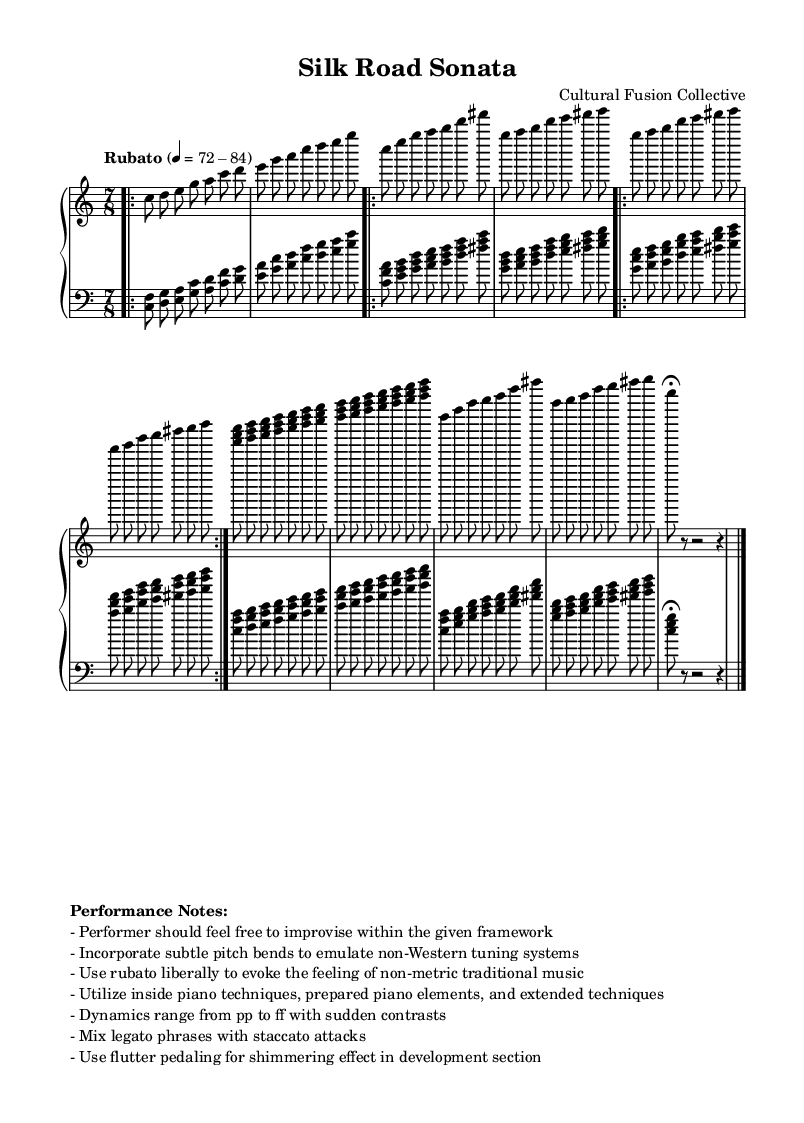What is the time signature of this music? The time signature is indicated at the beginning of the score, shown as 7/8. This is found in the section that specifies the rhythmic structure of the piece.
Answer: 7/8 What is the range of dynamics used in the piece? The dynamics range from "pp" (pianissimo) to "ff" (fortissimo), as noted in the performance notes section, indicating the extremes of quiet and loud playing within the composition.
Answer: pp to ff What is the tempo marking for the piece? The tempo marking is found in the score, indicating "Rubato" with a metronome marking of 72-84. This defines the overall speed and style of performance for the piece.
Answer: Rubato 72-84 What two techniques should performers incorporate to emulate non-Western traditions? The performance notes specify incorporating "subtle pitch bends" and "flutter pedaling." These techniques reflect the influence of non-Western musical traditions and invite improvisation into the performance.
Answer: Subtle pitch bends and flutter pedaling How many distinct themes are presented in the piece? The score contains two distinct themes, labeled as Theme A and Theme B. Each theme showcases unique melodic content and plays a significant role in the overall structure of the composition.
Answer: Two themes What is the overall effect intended through the use of rubato? The performer is encouraged to "use rubato liberally to evoke the feeling of non-metric traditional music," allowing for expressiveness and elasticity in the tempo, creating a fluid musical experience.
Answer: Non-metric expressiveness 